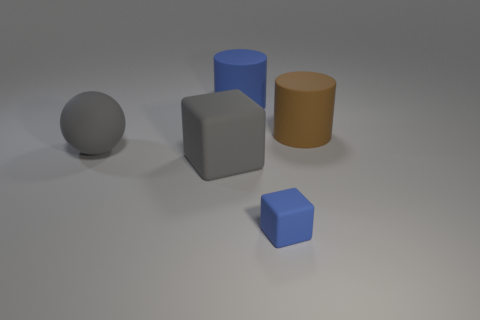Add 2 brown cylinders. How many objects exist? 7 Subtract all cylinders. How many objects are left? 3 Add 2 big gray rubber objects. How many big gray rubber objects are left? 4 Add 4 big gray matte things. How many big gray matte things exist? 6 Subtract 0 red cubes. How many objects are left? 5 Subtract all large red metal blocks. Subtract all big brown matte things. How many objects are left? 4 